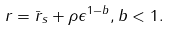<formula> <loc_0><loc_0><loc_500><loc_500>r = { \bar { r } } _ { s } + \rho \epsilon ^ { 1 - b } , b < 1 .</formula> 